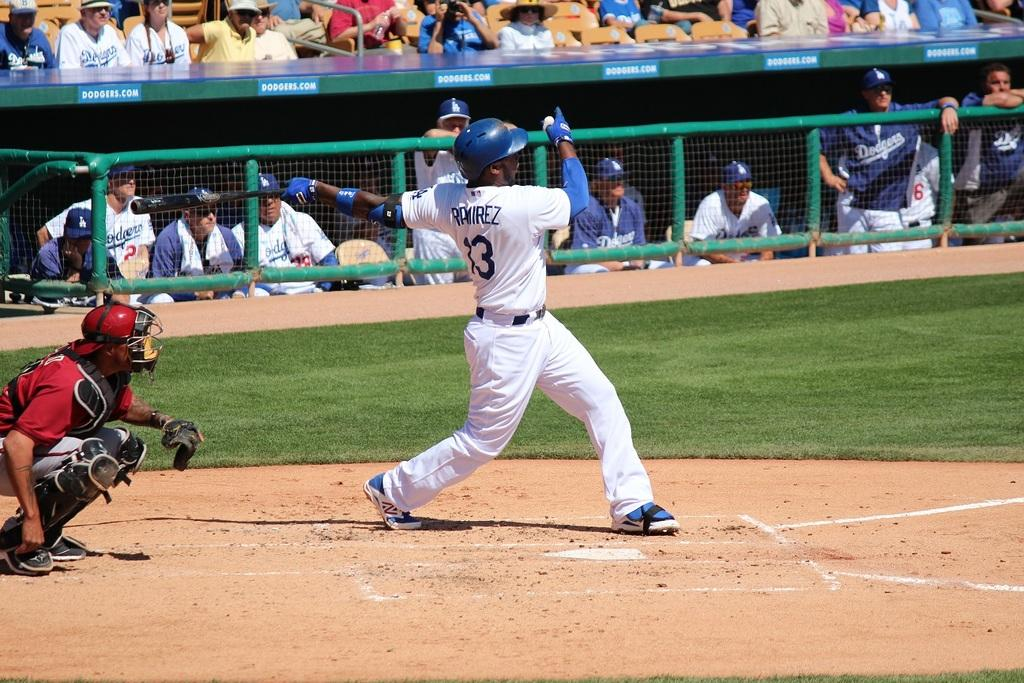<image>
Summarize the visual content of the image. Baseball player Ramirez is swinging his bat at Dodgers stadium. 